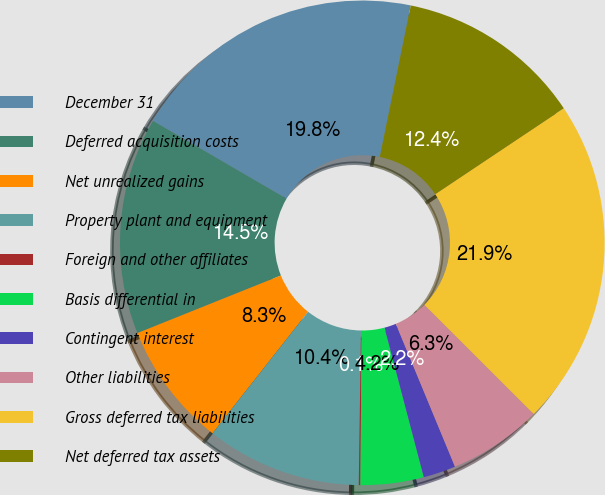Convert chart to OTSL. <chart><loc_0><loc_0><loc_500><loc_500><pie_chart><fcel>December 31<fcel>Deferred acquisition costs<fcel>Net unrealized gains<fcel>Property plant and equipment<fcel>Foreign and other affiliates<fcel>Basis differential in<fcel>Contingent interest<fcel>Other liabilities<fcel>Gross deferred tax liabilities<fcel>Net deferred tax assets<nl><fcel>19.81%<fcel>14.47%<fcel>8.32%<fcel>10.37%<fcel>0.11%<fcel>4.21%<fcel>2.16%<fcel>6.26%<fcel>21.86%<fcel>12.42%<nl></chart> 